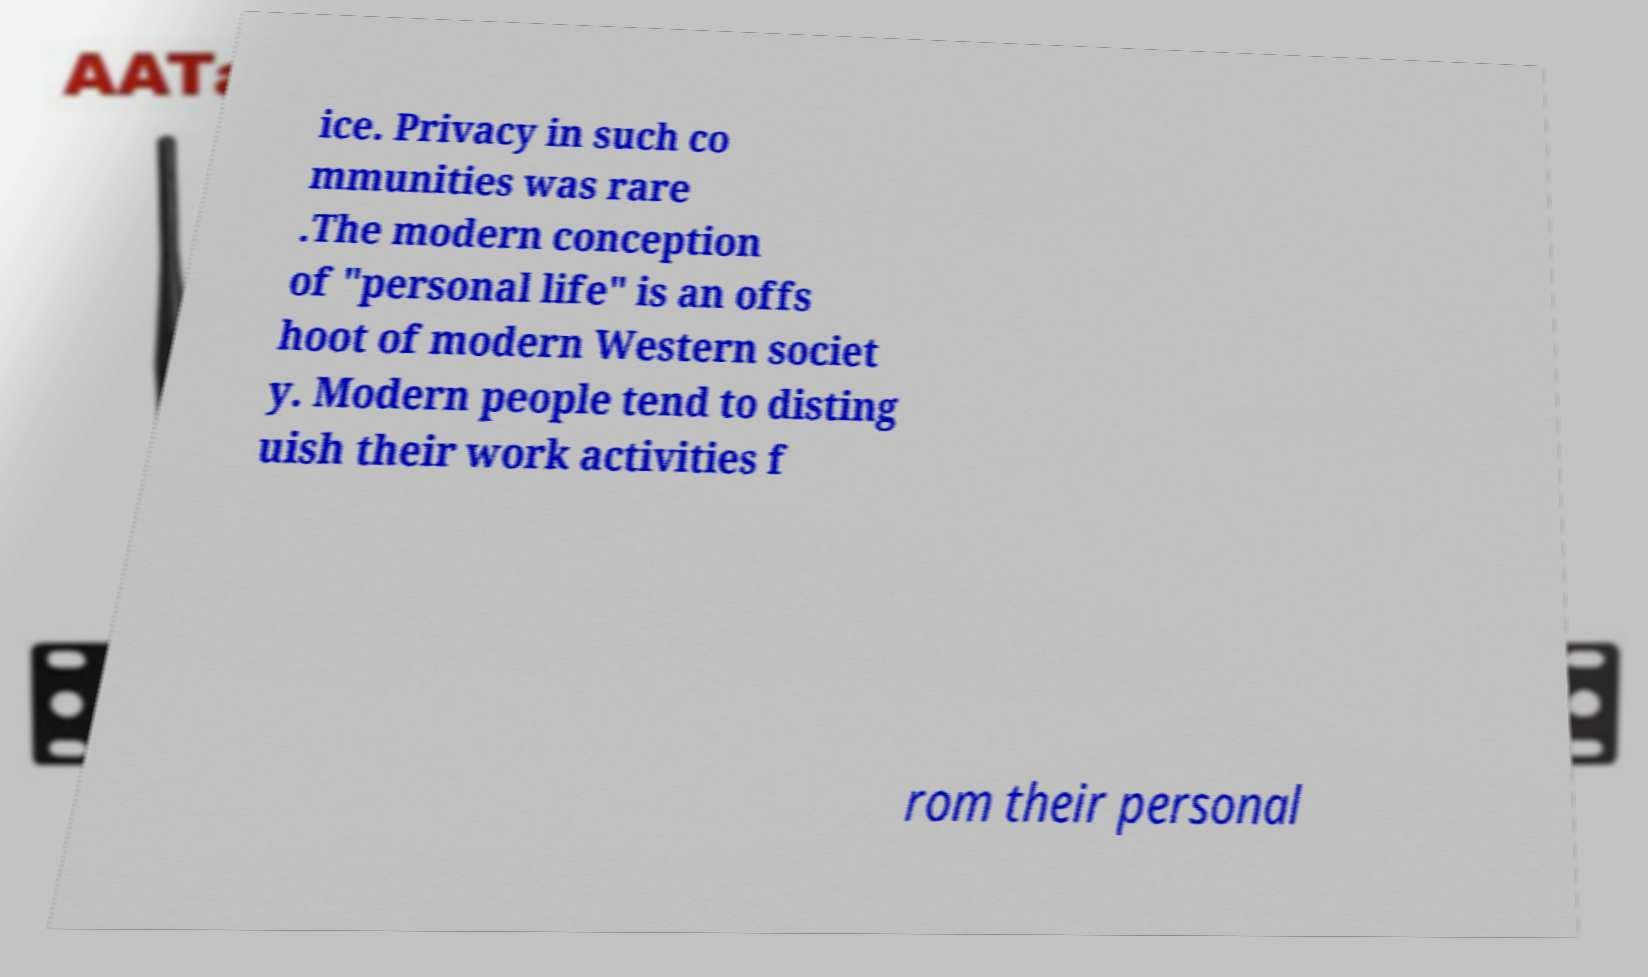I need the written content from this picture converted into text. Can you do that? ice. Privacy in such co mmunities was rare .The modern conception of "personal life" is an offs hoot of modern Western societ y. Modern people tend to disting uish their work activities f rom their personal 